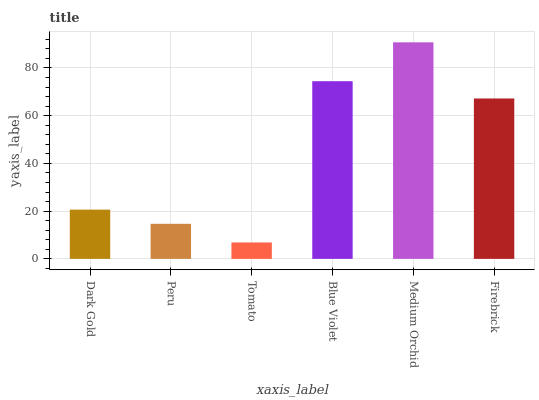Is Peru the minimum?
Answer yes or no. No. Is Peru the maximum?
Answer yes or no. No. Is Dark Gold greater than Peru?
Answer yes or no. Yes. Is Peru less than Dark Gold?
Answer yes or no. Yes. Is Peru greater than Dark Gold?
Answer yes or no. No. Is Dark Gold less than Peru?
Answer yes or no. No. Is Firebrick the high median?
Answer yes or no. Yes. Is Dark Gold the low median?
Answer yes or no. Yes. Is Tomato the high median?
Answer yes or no. No. Is Medium Orchid the low median?
Answer yes or no. No. 